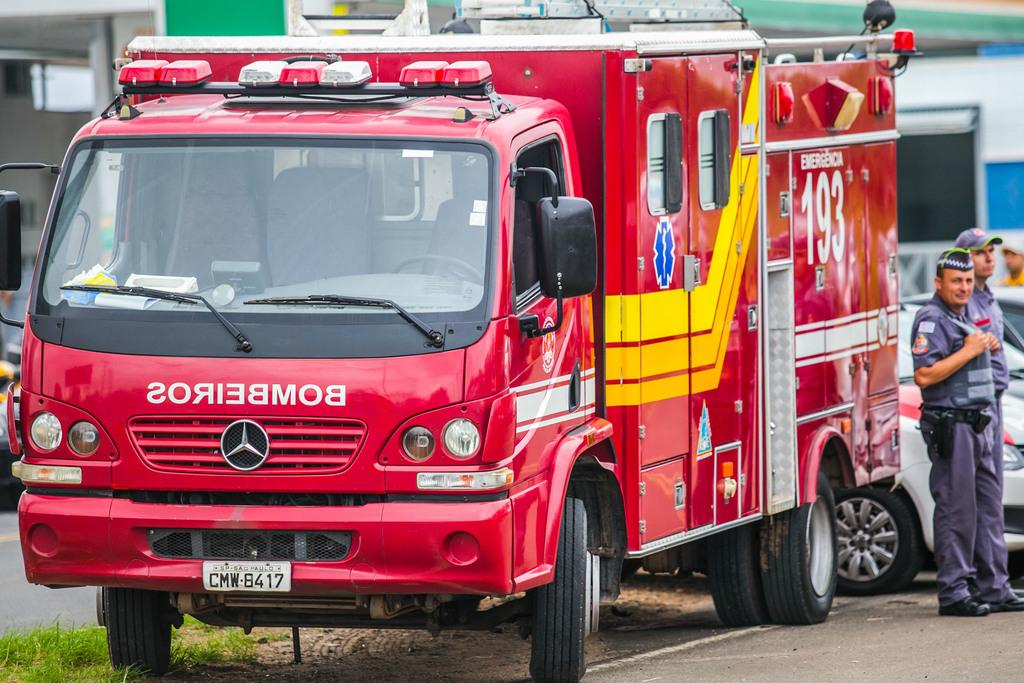What can be seen on the road in the image? There are vehicles on the road in the image. Where are the people located in the image? The two people are standing on the right side of the image. What are the people wearing? The people are wearing uniforms. What type of vegetation is visible at the bottom of the image? There is grass visible at the bottom of the image. How many lizards can be seen crawling on the back of the person in the image? There are no lizards present in the image, and therefore no such activity can be observed. 